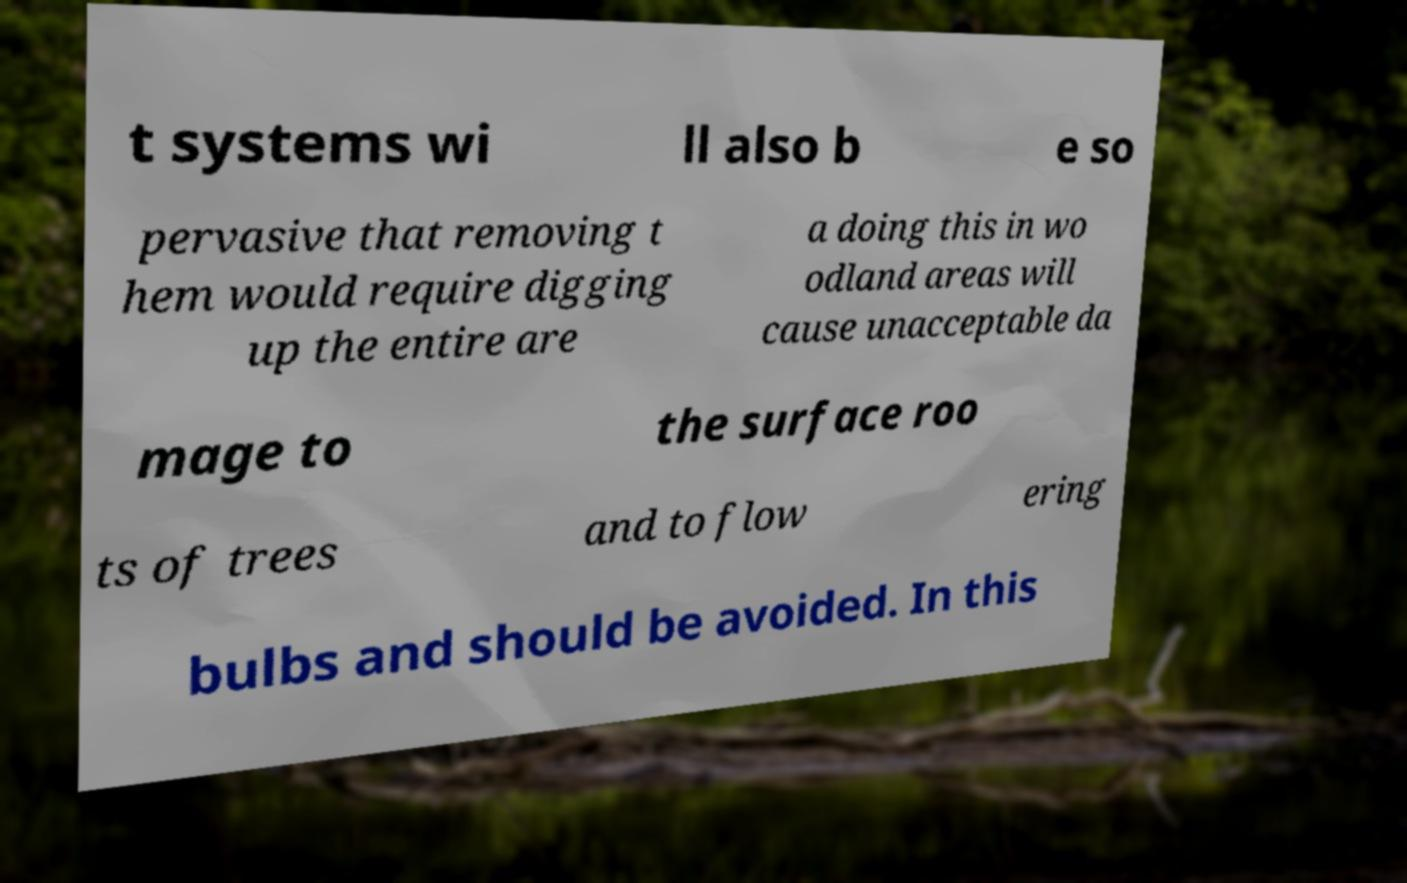Please identify and transcribe the text found in this image. t systems wi ll also b e so pervasive that removing t hem would require digging up the entire are a doing this in wo odland areas will cause unacceptable da mage to the surface roo ts of trees and to flow ering bulbs and should be avoided. In this 